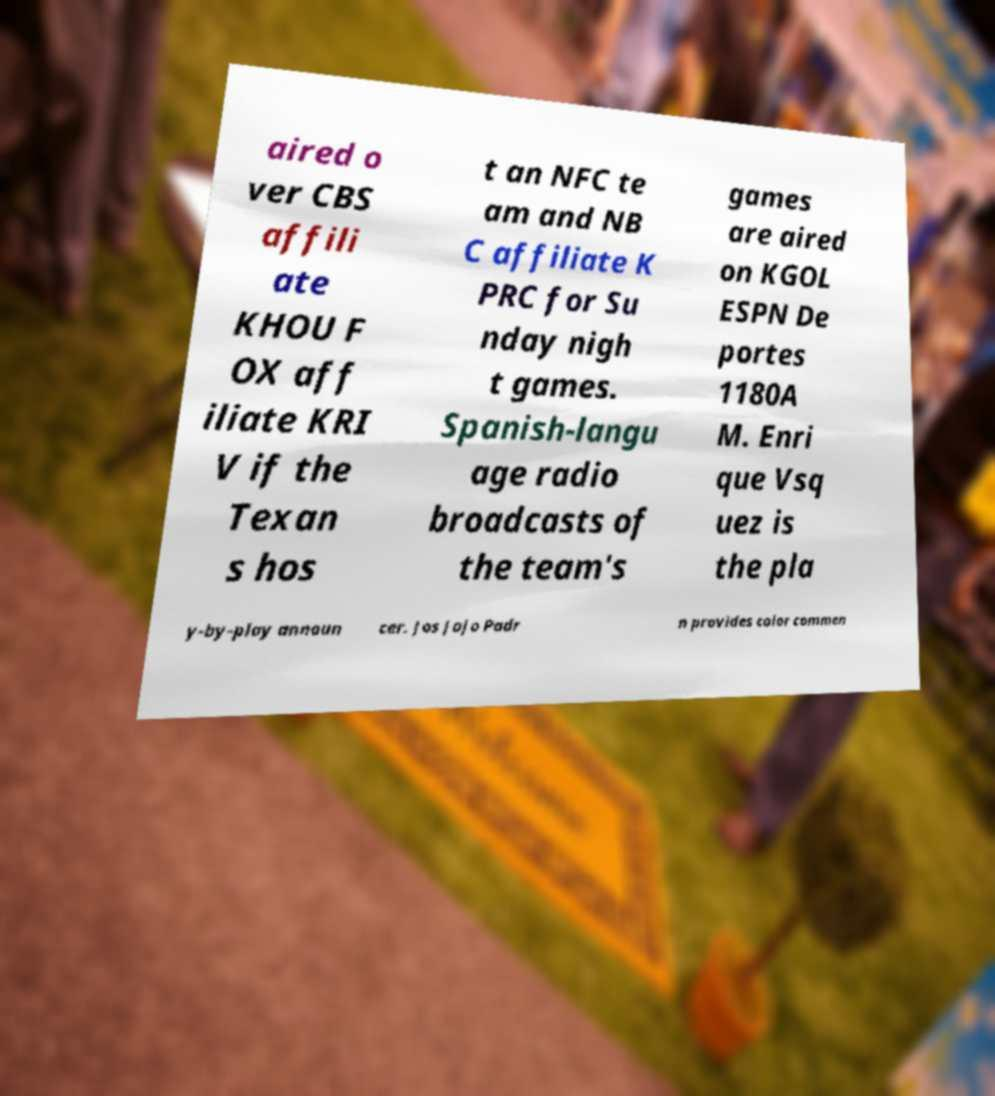Could you assist in decoding the text presented in this image and type it out clearly? aired o ver CBS affili ate KHOU F OX aff iliate KRI V if the Texan s hos t an NFC te am and NB C affiliate K PRC for Su nday nigh t games. Spanish-langu age radio broadcasts of the team's games are aired on KGOL ESPN De portes 1180A M. Enri que Vsq uez is the pla y-by-play announ cer. Jos Jojo Padr n provides color commen 